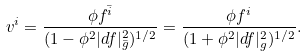<formula> <loc_0><loc_0><loc_500><loc_500>v ^ { i } = \frac { \phi f ^ { \bar { i } } } { ( 1 - \phi ^ { 2 } | d f | ^ { 2 } _ { \bar { g } } ) ^ { 1 / 2 } } = \frac { \phi f ^ { i } } { ( 1 + \phi ^ { 2 } | d f | ^ { 2 } _ { g } ) ^ { 1 / 2 } } .</formula> 